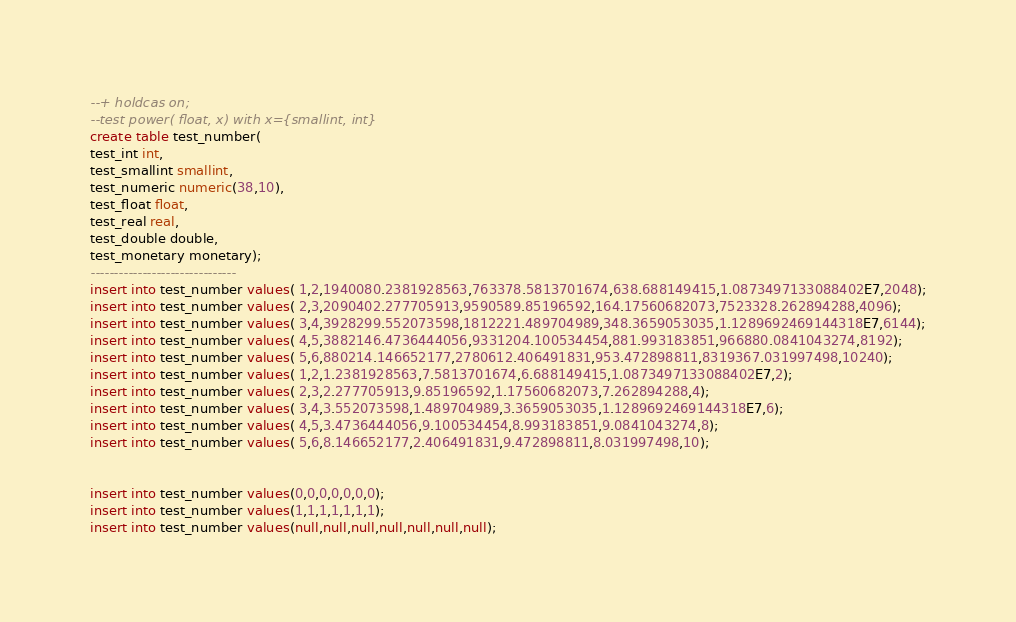Convert code to text. <code><loc_0><loc_0><loc_500><loc_500><_SQL_>--+ holdcas on;
--test power( float, x) with x={smallint, int}
create table test_number(
test_int int,		
test_smallint smallint,		
test_numeric numeric(38,10),		
test_float float,		
test_real real,		
test_double double, 		
test_monetary monetary);
-------------------------------
insert into test_number values( 1,2,1940080.2381928563,763378.5813701674,638.688149415,1.0873497133088402E7,2048);
insert into test_number values( 2,3,2090402.277705913,9590589.85196592,164.17560682073,7523328.262894288,4096);
insert into test_number values( 3,4,3928299.552073598,1812221.489704989,348.3659053035,1.1289692469144318E7,6144);
insert into test_number values( 4,5,3882146.4736444056,9331204.100534454,881.993183851,966880.0841043274,8192);
insert into test_number values( 5,6,880214.146652177,2780612.406491831,953.472898811,8319367.031997498,10240);
insert into test_number values( 1,2,1.2381928563,7.5813701674,6.688149415,1.0873497133088402E7,2);
insert into test_number values( 2,3,2.277705913,9.85196592,1.17560682073,7.262894288,4);
insert into test_number values( 3,4,3.552073598,1.489704989,3.3659053035,1.1289692469144318E7,6);
insert into test_number values( 4,5,3.4736444056,9.100534454,8.993183851,9.0841043274,8);
insert into test_number values( 5,6,8.146652177,2.406491831,9.472898811,8.031997498,10);


insert into test_number values(0,0,0,0,0,0,0);
insert into test_number values(1,1,1,1,1,1,1);
insert into test_number values(null,null,null,null,null,null,null);
</code> 